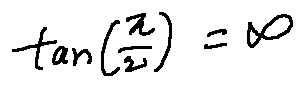Convert formula to latex. <formula><loc_0><loc_0><loc_500><loc_500>\tan ( \frac { \pi } { 2 } ) = \infty</formula> 